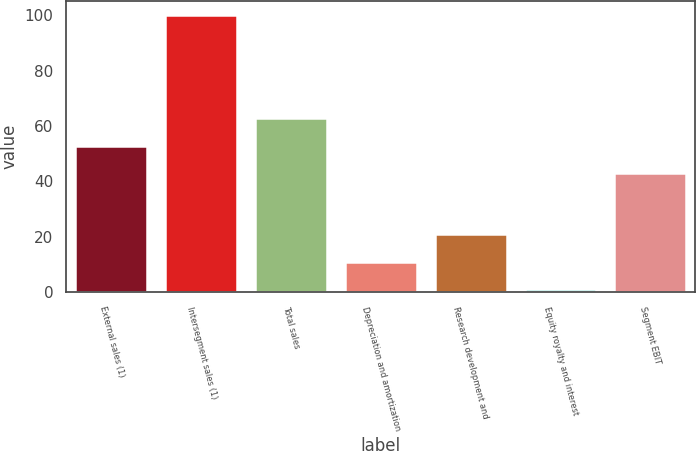<chart> <loc_0><loc_0><loc_500><loc_500><bar_chart><fcel>External sales (1)<fcel>Intersegment sales (1)<fcel>Total sales<fcel>Depreciation and amortization<fcel>Research development and<fcel>Equity royalty and interest<fcel>Segment EBIT<nl><fcel>52.9<fcel>100<fcel>62.8<fcel>10.9<fcel>20.8<fcel>1<fcel>43<nl></chart> 